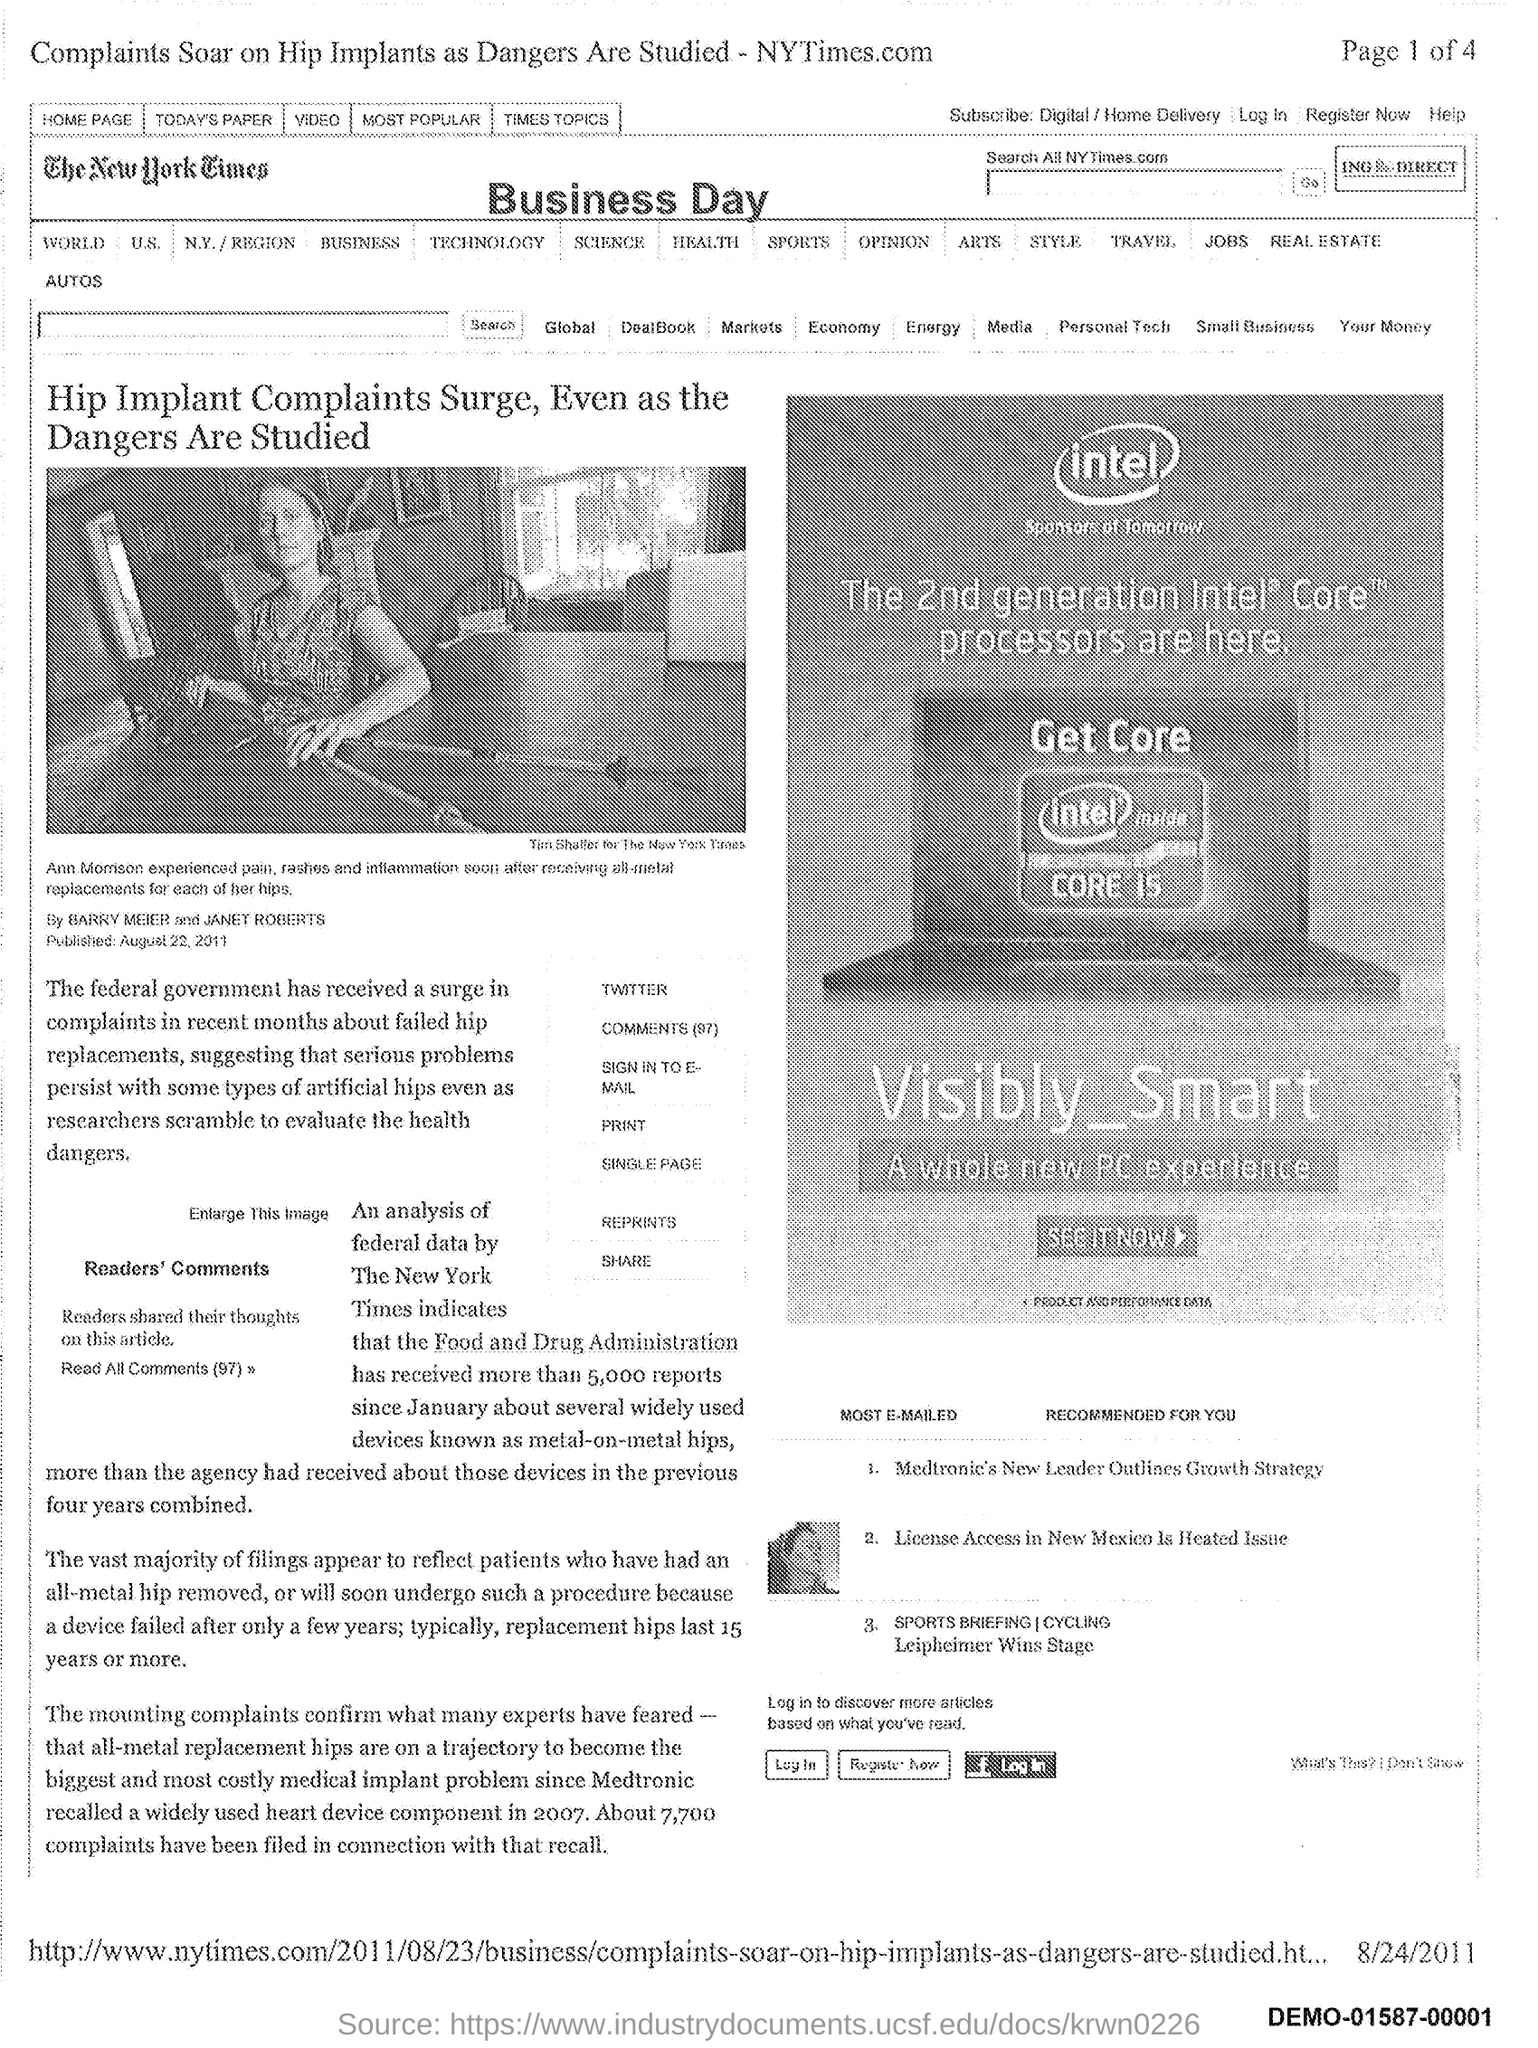Give some essential details in this illustration. The New York Times is the newspaper mentioned in the document. 